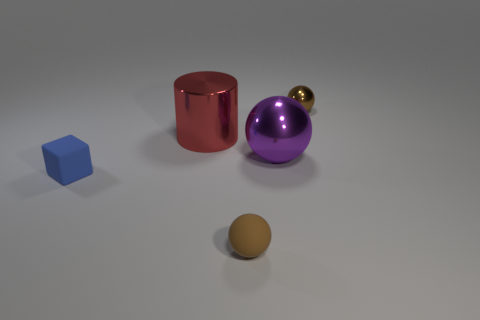Add 3 tiny brown rubber spheres. How many objects exist? 8 Subtract all cubes. How many objects are left? 4 Add 2 brown spheres. How many brown spheres exist? 4 Subtract 1 blue blocks. How many objects are left? 4 Subtract all purple blocks. Subtract all tiny blue cubes. How many objects are left? 4 Add 2 large cylinders. How many large cylinders are left? 3 